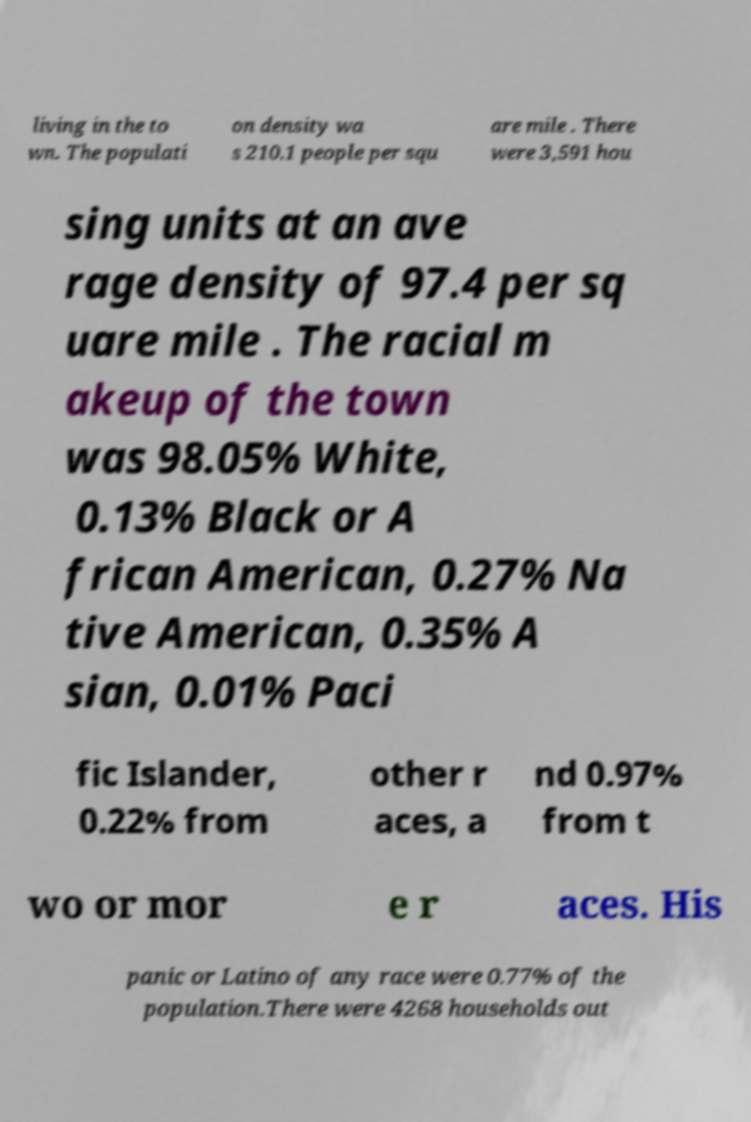Please identify and transcribe the text found in this image. living in the to wn. The populati on density wa s 210.1 people per squ are mile . There were 3,591 hou sing units at an ave rage density of 97.4 per sq uare mile . The racial m akeup of the town was 98.05% White, 0.13% Black or A frican American, 0.27% Na tive American, 0.35% A sian, 0.01% Paci fic Islander, 0.22% from other r aces, a nd 0.97% from t wo or mor e r aces. His panic or Latino of any race were 0.77% of the population.There were 4268 households out 